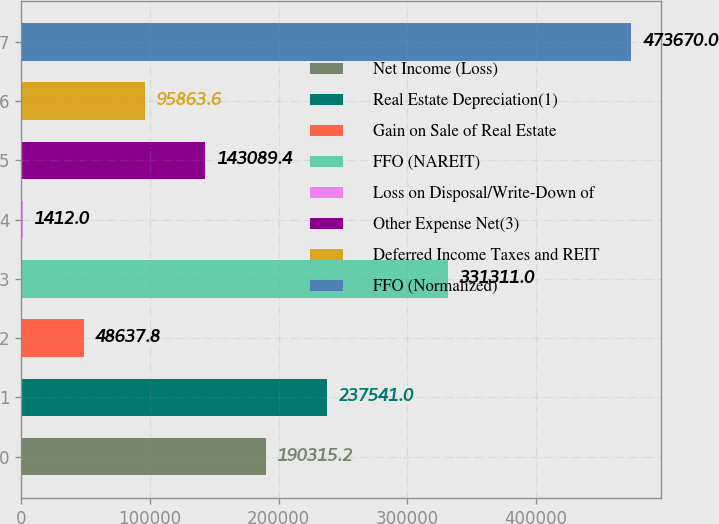Convert chart. <chart><loc_0><loc_0><loc_500><loc_500><bar_chart><fcel>Net Income (Loss)<fcel>Real Estate Depreciation(1)<fcel>Gain on Sale of Real Estate<fcel>FFO (NAREIT)<fcel>Loss on Disposal/Write-Down of<fcel>Other Expense Net(3)<fcel>Deferred Income Taxes and REIT<fcel>FFO (Normalized)<nl><fcel>190315<fcel>237541<fcel>48637.8<fcel>331311<fcel>1412<fcel>143089<fcel>95863.6<fcel>473670<nl></chart> 